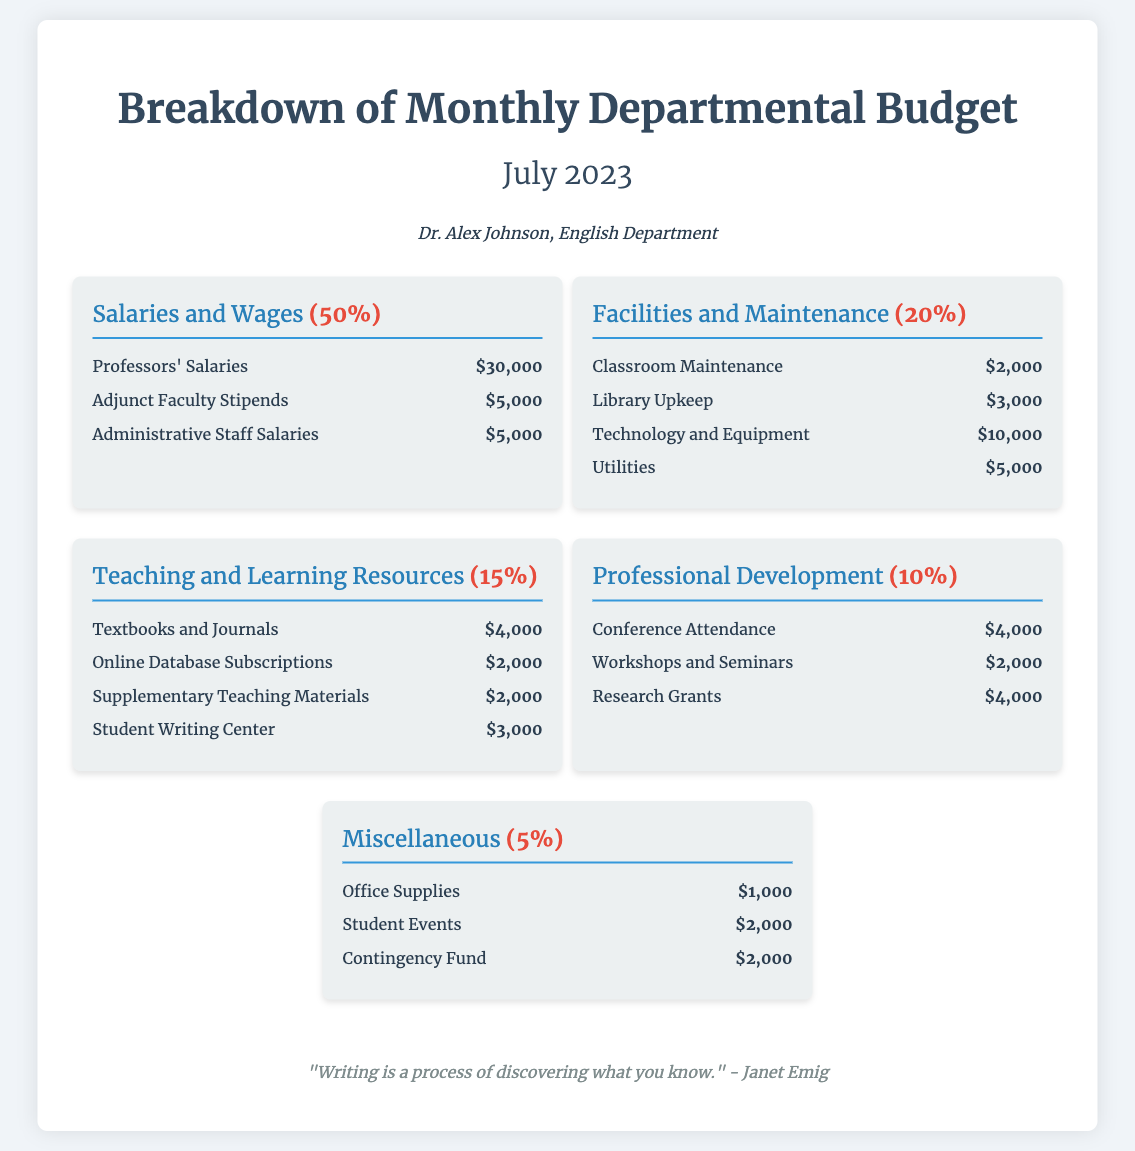What is the total budget percentage for Salaries and Wages? The total budget percentage for Salaries and Wages is explicitly stated in the document as 50%.
Answer: 50% How much is allocated for Conference Attendance? The amount allocated for Conference Attendance is broken down under Professional Development and is listed as $4,000.
Answer: $4,000 What percentage of the budget is dedicated to Miscellaneous expenses? The document indicates that Miscellaneous expenses account for 5% of the total budget.
Answer: 5% Who is the department head mentioned in the document? The document identifies Dr. Alex Johnson as the head of the English Department.
Answer: Dr. Alex Johnson What is the total amount allocated for Teaching and Learning Resources? Total for Teaching and Learning Resources is calculated by adding the individual amounts: $4,000 + $2,000 + $2,000 + $3,000 = $11,000.
Answer: $11,000 How many categories are presented in the budget breakdown? The document presents a total of five budget categories: Salaries and Wages, Facilities and Maintenance, Teaching and Learning Resources, Professional Development, and Miscellaneous.
Answer: Five What is the largest expense item under Facilities and Maintenance? The largest expense item under Facilities and Maintenance is Technology and Equipment, which costs $10,000.
Answer: Technology and Equipment How much is allocated for Student Writing Center? The amount allocated for Student Writing Center is provided in the Teaching and Learning Resources section as $3,000.
Answer: $3,000 What percentage of the budget is assigned to Professional Development? The budget percentage assigned to Professional Development is directly stated as 10%.
Answer: 10% What does the quote at the bottom of the document reference? The quote references the process of writing as a means of discovering knowledge, attributed to Janet Emig.
Answer: "Writing is a process of discovering what you know." 